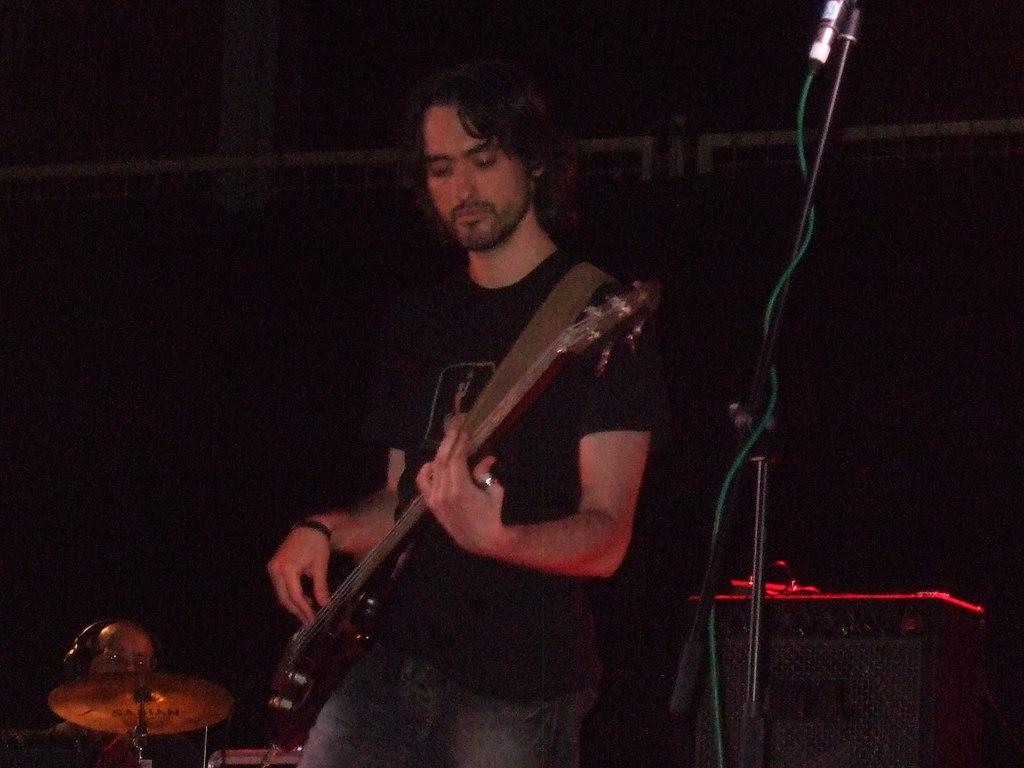What is the man in the image doing? The man is playing a guitar in the image. What object is the man using to amplify his voice? There is a microphone in the image. What is the purpose of the stand in the image? The stand is likely used to hold the man's sheet music or lyrics. What musical instrument can be seen in the background of the image? There are drums in the background of the image. Where is the man's sister standing in the image? There is no mention of a sister in the image, so we cannot determine her location. 